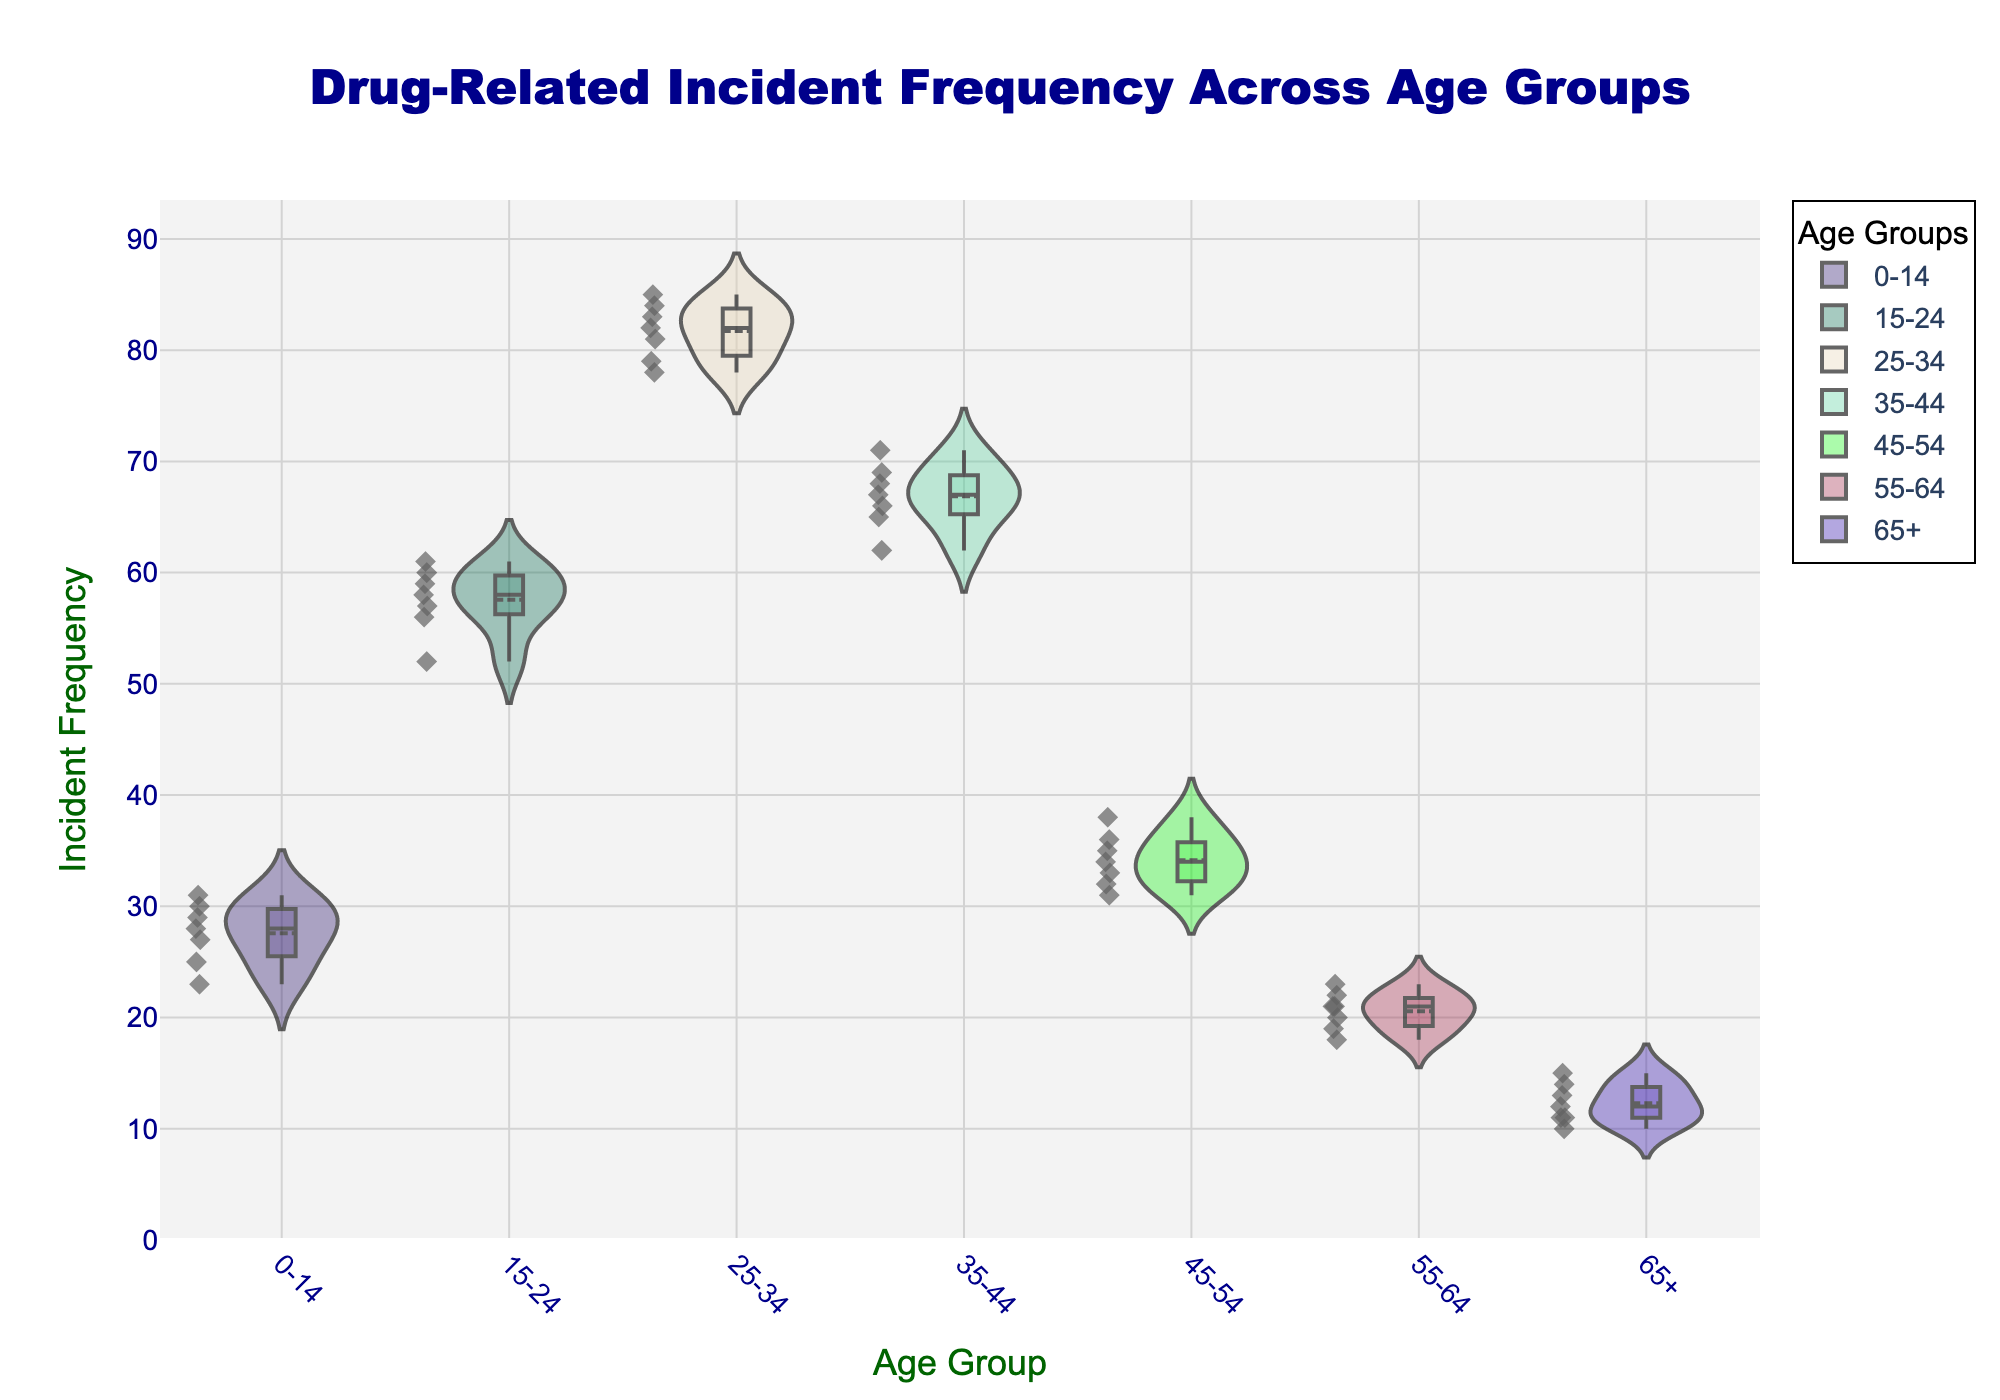What's the title of the chart? The title is located at the top center of the chart. It says, "Drug-Related Incident Frequency Across Age Groups".
Answer: Drug-Related Incident Frequency Across Age Groups What is the age group with the highest incident frequency? By examining the violin plots, you can see that the group with the highest frequencies is 25-34. The range of values is higher compared to other groups.
Answer: 25-34 Which age group has the lowest median incident frequency? Median incident frequency is represented by the central boxplot line within each violin plot. The group with the lowest median is 65+.
Answer: 65+ How many age groups are displayed in the chart? There are seven distinct age groups: 0-14, 15-24, 25-34, 35-44, 45-54, 55-64, and 65+. Count these groups on the x-axis.
Answer: 7 What's the interquartile range (IQR) for the 45-54 age group? The interquartile range is the distance between the 25th percentile (Q1) and the 75th percentile (Q3) in the box plot. For 45-54, Q1 is 32 and Q3 is 35, so IQR is 35 - 32 = 3.
Answer: 3 Which age group shows the greatest variability in incident frequencies? The widest violin plot indicates the greatest variability. The 25-34 age group shows the widest and most dispersed data points.
Answer: 25-34 Which age group has more incidents on average: 0-14 or 15-24? The average is indicated by the white dot within each violin plot. By comparing these dots, the average for 0-14 is around 27 while for 15-24 is around 58. Therefore, 15-24 has a higher average.
Answer: 15-24 What’s the median value of the 35-44 age group? The median is represented by the line in the middle of the box plot. For 35-44, this value is approximately 67.
Answer: 67 Which age groups have incident frequencies exceeding 80? The box or points lying above 80 straight line on the y-axis must be checked. Only the 25-34 age group has incident frequencies exceeding 80.
Answer: 25-34 What do the black lines inside each violin plot represent? The black lines are part of the box plot overlay. They represent the minimum, 25th percentile (Q1), median, 75th percentile (Q3), and maximum values of the data within each age group.
Answer: Minimum, Q1, median, Q3, maximum 